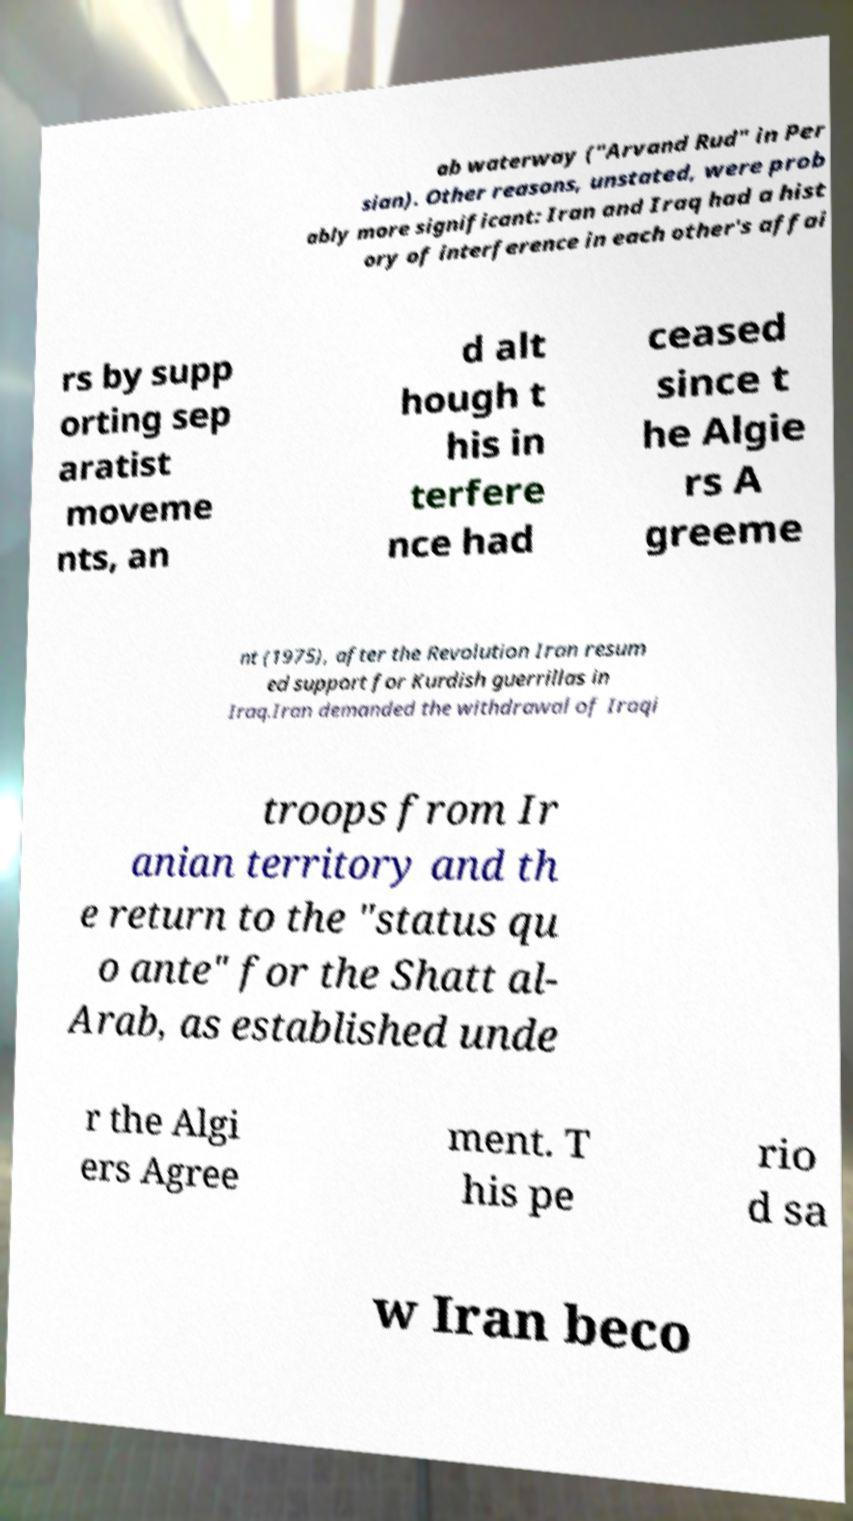There's text embedded in this image that I need extracted. Can you transcribe it verbatim? ab waterway ("Arvand Rud" in Per sian). Other reasons, unstated, were prob ably more significant: Iran and Iraq had a hist ory of interference in each other's affai rs by supp orting sep aratist moveme nts, an d alt hough t his in terfere nce had ceased since t he Algie rs A greeme nt (1975), after the Revolution Iran resum ed support for Kurdish guerrillas in Iraq.Iran demanded the withdrawal of Iraqi troops from Ir anian territory and th e return to the "status qu o ante" for the Shatt al- Arab, as established unde r the Algi ers Agree ment. T his pe rio d sa w Iran beco 